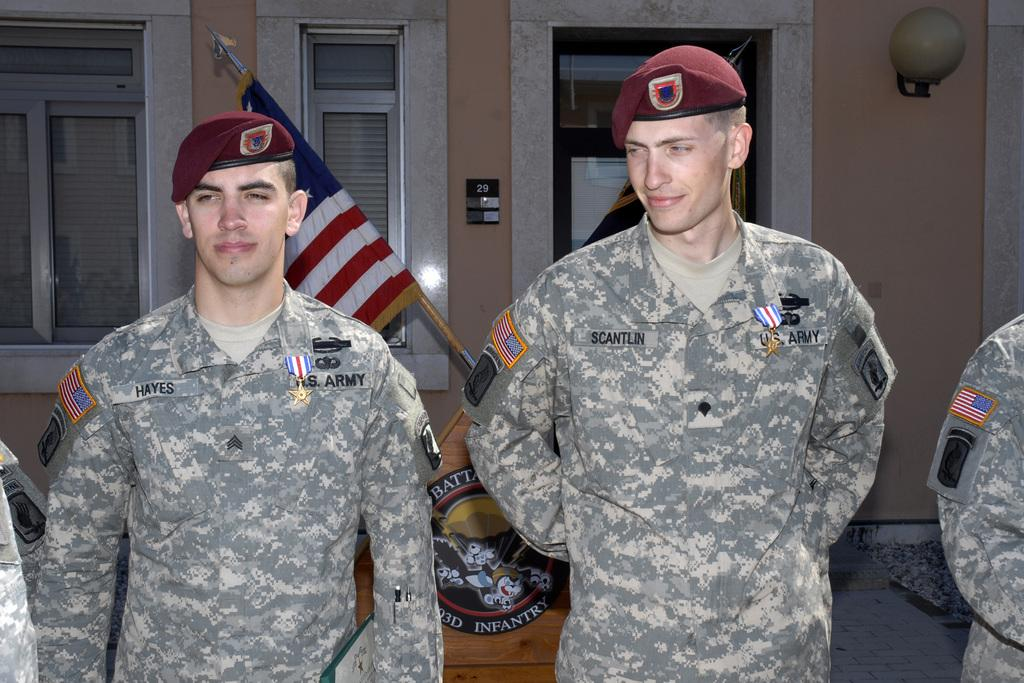<image>
Give a short and clear explanation of the subsequent image. Two men in U.S. Army uniforms stand proud. 